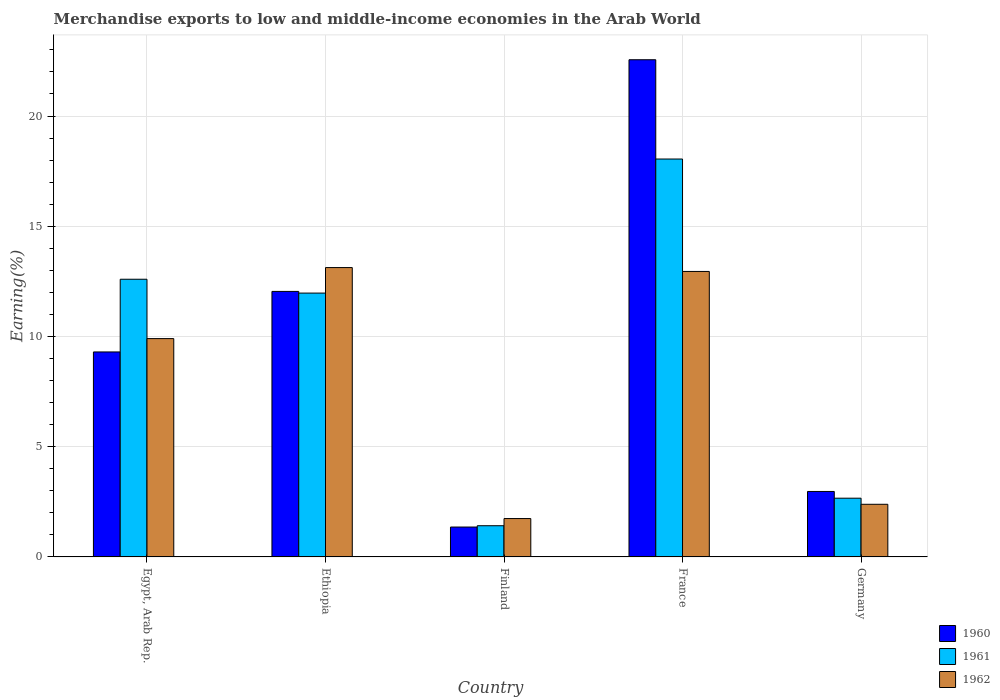How many groups of bars are there?
Offer a very short reply. 5. Are the number of bars per tick equal to the number of legend labels?
Keep it short and to the point. Yes. How many bars are there on the 5th tick from the left?
Your answer should be very brief. 3. What is the label of the 2nd group of bars from the left?
Give a very brief answer. Ethiopia. What is the percentage of amount earned from merchandise exports in 1961 in Ethiopia?
Give a very brief answer. 11.97. Across all countries, what is the maximum percentage of amount earned from merchandise exports in 1960?
Ensure brevity in your answer.  22.55. Across all countries, what is the minimum percentage of amount earned from merchandise exports in 1960?
Make the answer very short. 1.36. In which country was the percentage of amount earned from merchandise exports in 1961 maximum?
Your answer should be very brief. France. What is the total percentage of amount earned from merchandise exports in 1962 in the graph?
Your answer should be very brief. 40.11. What is the difference between the percentage of amount earned from merchandise exports in 1960 in Egypt, Arab Rep. and that in Germany?
Your response must be concise. 6.33. What is the difference between the percentage of amount earned from merchandise exports in 1961 in Ethiopia and the percentage of amount earned from merchandise exports in 1960 in France?
Provide a succinct answer. -10.58. What is the average percentage of amount earned from merchandise exports in 1962 per country?
Offer a terse response. 8.02. What is the difference between the percentage of amount earned from merchandise exports of/in 1961 and percentage of amount earned from merchandise exports of/in 1962 in Germany?
Your response must be concise. 0.28. What is the ratio of the percentage of amount earned from merchandise exports in 1961 in Finland to that in Germany?
Ensure brevity in your answer.  0.53. Is the percentage of amount earned from merchandise exports in 1960 in Ethiopia less than that in Germany?
Your answer should be compact. No. What is the difference between the highest and the second highest percentage of amount earned from merchandise exports in 1961?
Your answer should be compact. 6.08. What is the difference between the highest and the lowest percentage of amount earned from merchandise exports in 1960?
Keep it short and to the point. 21.2. Is the sum of the percentage of amount earned from merchandise exports in 1962 in Finland and Germany greater than the maximum percentage of amount earned from merchandise exports in 1961 across all countries?
Provide a succinct answer. No. What does the 1st bar from the right in Germany represents?
Your answer should be very brief. 1962. Is it the case that in every country, the sum of the percentage of amount earned from merchandise exports in 1962 and percentage of amount earned from merchandise exports in 1961 is greater than the percentage of amount earned from merchandise exports in 1960?
Your answer should be compact. Yes. Are all the bars in the graph horizontal?
Ensure brevity in your answer.  No. How many countries are there in the graph?
Your response must be concise. 5. What is the difference between two consecutive major ticks on the Y-axis?
Offer a terse response. 5. Are the values on the major ticks of Y-axis written in scientific E-notation?
Offer a terse response. No. Does the graph contain any zero values?
Keep it short and to the point. No. Does the graph contain grids?
Offer a terse response. Yes. Where does the legend appear in the graph?
Ensure brevity in your answer.  Bottom right. How many legend labels are there?
Keep it short and to the point. 3. What is the title of the graph?
Make the answer very short. Merchandise exports to low and middle-income economies in the Arab World. What is the label or title of the X-axis?
Provide a short and direct response. Country. What is the label or title of the Y-axis?
Provide a short and direct response. Earning(%). What is the Earning(%) in 1960 in Egypt, Arab Rep.?
Ensure brevity in your answer.  9.3. What is the Earning(%) of 1961 in Egypt, Arab Rep.?
Ensure brevity in your answer.  12.6. What is the Earning(%) in 1962 in Egypt, Arab Rep.?
Offer a terse response. 9.9. What is the Earning(%) in 1960 in Ethiopia?
Provide a short and direct response. 12.04. What is the Earning(%) of 1961 in Ethiopia?
Ensure brevity in your answer.  11.97. What is the Earning(%) in 1962 in Ethiopia?
Give a very brief answer. 13.12. What is the Earning(%) of 1960 in Finland?
Offer a very short reply. 1.36. What is the Earning(%) in 1961 in Finland?
Ensure brevity in your answer.  1.42. What is the Earning(%) in 1962 in Finland?
Keep it short and to the point. 1.74. What is the Earning(%) of 1960 in France?
Give a very brief answer. 22.55. What is the Earning(%) in 1961 in France?
Your response must be concise. 18.05. What is the Earning(%) of 1962 in France?
Provide a short and direct response. 12.95. What is the Earning(%) in 1960 in Germany?
Make the answer very short. 2.97. What is the Earning(%) in 1961 in Germany?
Make the answer very short. 2.66. What is the Earning(%) of 1962 in Germany?
Offer a terse response. 2.39. Across all countries, what is the maximum Earning(%) of 1960?
Your answer should be compact. 22.55. Across all countries, what is the maximum Earning(%) in 1961?
Provide a succinct answer. 18.05. Across all countries, what is the maximum Earning(%) of 1962?
Your answer should be very brief. 13.12. Across all countries, what is the minimum Earning(%) of 1960?
Provide a short and direct response. 1.36. Across all countries, what is the minimum Earning(%) of 1961?
Offer a very short reply. 1.42. Across all countries, what is the minimum Earning(%) of 1962?
Keep it short and to the point. 1.74. What is the total Earning(%) of 1960 in the graph?
Your answer should be compact. 48.22. What is the total Earning(%) of 1961 in the graph?
Ensure brevity in your answer.  46.69. What is the total Earning(%) of 1962 in the graph?
Offer a very short reply. 40.11. What is the difference between the Earning(%) of 1960 in Egypt, Arab Rep. and that in Ethiopia?
Your answer should be very brief. -2.75. What is the difference between the Earning(%) in 1961 in Egypt, Arab Rep. and that in Ethiopia?
Give a very brief answer. 0.63. What is the difference between the Earning(%) in 1962 in Egypt, Arab Rep. and that in Ethiopia?
Provide a short and direct response. -3.22. What is the difference between the Earning(%) of 1960 in Egypt, Arab Rep. and that in Finland?
Make the answer very short. 7.94. What is the difference between the Earning(%) in 1961 in Egypt, Arab Rep. and that in Finland?
Offer a terse response. 11.18. What is the difference between the Earning(%) in 1962 in Egypt, Arab Rep. and that in Finland?
Keep it short and to the point. 8.16. What is the difference between the Earning(%) of 1960 in Egypt, Arab Rep. and that in France?
Give a very brief answer. -13.25. What is the difference between the Earning(%) of 1961 in Egypt, Arab Rep. and that in France?
Make the answer very short. -5.45. What is the difference between the Earning(%) in 1962 in Egypt, Arab Rep. and that in France?
Your answer should be compact. -3.05. What is the difference between the Earning(%) in 1960 in Egypt, Arab Rep. and that in Germany?
Keep it short and to the point. 6.33. What is the difference between the Earning(%) of 1961 in Egypt, Arab Rep. and that in Germany?
Offer a very short reply. 9.93. What is the difference between the Earning(%) of 1962 in Egypt, Arab Rep. and that in Germany?
Give a very brief answer. 7.52. What is the difference between the Earning(%) of 1960 in Ethiopia and that in Finland?
Ensure brevity in your answer.  10.69. What is the difference between the Earning(%) in 1961 in Ethiopia and that in Finland?
Offer a very short reply. 10.55. What is the difference between the Earning(%) in 1962 in Ethiopia and that in Finland?
Offer a terse response. 11.38. What is the difference between the Earning(%) in 1960 in Ethiopia and that in France?
Offer a terse response. -10.51. What is the difference between the Earning(%) in 1961 in Ethiopia and that in France?
Your answer should be compact. -6.08. What is the difference between the Earning(%) of 1962 in Ethiopia and that in France?
Your answer should be very brief. 0.18. What is the difference between the Earning(%) in 1960 in Ethiopia and that in Germany?
Your answer should be compact. 9.07. What is the difference between the Earning(%) in 1961 in Ethiopia and that in Germany?
Keep it short and to the point. 9.3. What is the difference between the Earning(%) in 1962 in Ethiopia and that in Germany?
Make the answer very short. 10.74. What is the difference between the Earning(%) in 1960 in Finland and that in France?
Your answer should be compact. -21.2. What is the difference between the Earning(%) in 1961 in Finland and that in France?
Ensure brevity in your answer.  -16.63. What is the difference between the Earning(%) in 1962 in Finland and that in France?
Your answer should be very brief. -11.21. What is the difference between the Earning(%) of 1960 in Finland and that in Germany?
Provide a short and direct response. -1.61. What is the difference between the Earning(%) in 1961 in Finland and that in Germany?
Your answer should be compact. -1.25. What is the difference between the Earning(%) in 1962 in Finland and that in Germany?
Give a very brief answer. -0.65. What is the difference between the Earning(%) in 1960 in France and that in Germany?
Your response must be concise. 19.58. What is the difference between the Earning(%) of 1961 in France and that in Germany?
Your answer should be compact. 15.38. What is the difference between the Earning(%) in 1962 in France and that in Germany?
Your answer should be compact. 10.56. What is the difference between the Earning(%) of 1960 in Egypt, Arab Rep. and the Earning(%) of 1961 in Ethiopia?
Keep it short and to the point. -2.67. What is the difference between the Earning(%) of 1960 in Egypt, Arab Rep. and the Earning(%) of 1962 in Ethiopia?
Your answer should be very brief. -3.83. What is the difference between the Earning(%) in 1961 in Egypt, Arab Rep. and the Earning(%) in 1962 in Ethiopia?
Offer a terse response. -0.53. What is the difference between the Earning(%) in 1960 in Egypt, Arab Rep. and the Earning(%) in 1961 in Finland?
Your answer should be very brief. 7.88. What is the difference between the Earning(%) in 1960 in Egypt, Arab Rep. and the Earning(%) in 1962 in Finland?
Give a very brief answer. 7.56. What is the difference between the Earning(%) of 1961 in Egypt, Arab Rep. and the Earning(%) of 1962 in Finland?
Your answer should be very brief. 10.85. What is the difference between the Earning(%) of 1960 in Egypt, Arab Rep. and the Earning(%) of 1961 in France?
Offer a terse response. -8.75. What is the difference between the Earning(%) in 1960 in Egypt, Arab Rep. and the Earning(%) in 1962 in France?
Your response must be concise. -3.65. What is the difference between the Earning(%) of 1961 in Egypt, Arab Rep. and the Earning(%) of 1962 in France?
Your answer should be very brief. -0.35. What is the difference between the Earning(%) of 1960 in Egypt, Arab Rep. and the Earning(%) of 1961 in Germany?
Provide a short and direct response. 6.63. What is the difference between the Earning(%) of 1960 in Egypt, Arab Rep. and the Earning(%) of 1962 in Germany?
Provide a short and direct response. 6.91. What is the difference between the Earning(%) in 1961 in Egypt, Arab Rep. and the Earning(%) in 1962 in Germany?
Give a very brief answer. 10.21. What is the difference between the Earning(%) of 1960 in Ethiopia and the Earning(%) of 1961 in Finland?
Offer a terse response. 10.63. What is the difference between the Earning(%) in 1960 in Ethiopia and the Earning(%) in 1962 in Finland?
Offer a terse response. 10.3. What is the difference between the Earning(%) in 1961 in Ethiopia and the Earning(%) in 1962 in Finland?
Provide a succinct answer. 10.23. What is the difference between the Earning(%) in 1960 in Ethiopia and the Earning(%) in 1961 in France?
Keep it short and to the point. -6.01. What is the difference between the Earning(%) of 1960 in Ethiopia and the Earning(%) of 1962 in France?
Your answer should be compact. -0.91. What is the difference between the Earning(%) of 1961 in Ethiopia and the Earning(%) of 1962 in France?
Your answer should be very brief. -0.98. What is the difference between the Earning(%) in 1960 in Ethiopia and the Earning(%) in 1961 in Germany?
Ensure brevity in your answer.  9.38. What is the difference between the Earning(%) in 1960 in Ethiopia and the Earning(%) in 1962 in Germany?
Your response must be concise. 9.66. What is the difference between the Earning(%) of 1961 in Ethiopia and the Earning(%) of 1962 in Germany?
Ensure brevity in your answer.  9.58. What is the difference between the Earning(%) in 1960 in Finland and the Earning(%) in 1961 in France?
Provide a succinct answer. -16.69. What is the difference between the Earning(%) of 1960 in Finland and the Earning(%) of 1962 in France?
Provide a short and direct response. -11.59. What is the difference between the Earning(%) of 1961 in Finland and the Earning(%) of 1962 in France?
Offer a terse response. -11.53. What is the difference between the Earning(%) in 1960 in Finland and the Earning(%) in 1961 in Germany?
Your response must be concise. -1.31. What is the difference between the Earning(%) of 1960 in Finland and the Earning(%) of 1962 in Germany?
Ensure brevity in your answer.  -1.03. What is the difference between the Earning(%) in 1961 in Finland and the Earning(%) in 1962 in Germany?
Provide a succinct answer. -0.97. What is the difference between the Earning(%) of 1960 in France and the Earning(%) of 1961 in Germany?
Make the answer very short. 19.89. What is the difference between the Earning(%) in 1960 in France and the Earning(%) in 1962 in Germany?
Make the answer very short. 20.16. What is the difference between the Earning(%) of 1961 in France and the Earning(%) of 1962 in Germany?
Ensure brevity in your answer.  15.66. What is the average Earning(%) in 1960 per country?
Provide a succinct answer. 9.64. What is the average Earning(%) in 1961 per country?
Provide a succinct answer. 9.34. What is the average Earning(%) in 1962 per country?
Give a very brief answer. 8.02. What is the difference between the Earning(%) of 1960 and Earning(%) of 1961 in Egypt, Arab Rep.?
Your response must be concise. -3.3. What is the difference between the Earning(%) in 1960 and Earning(%) in 1962 in Egypt, Arab Rep.?
Your response must be concise. -0.61. What is the difference between the Earning(%) of 1961 and Earning(%) of 1962 in Egypt, Arab Rep.?
Keep it short and to the point. 2.69. What is the difference between the Earning(%) in 1960 and Earning(%) in 1961 in Ethiopia?
Offer a terse response. 0.08. What is the difference between the Earning(%) of 1960 and Earning(%) of 1962 in Ethiopia?
Ensure brevity in your answer.  -1.08. What is the difference between the Earning(%) of 1961 and Earning(%) of 1962 in Ethiopia?
Offer a terse response. -1.16. What is the difference between the Earning(%) in 1960 and Earning(%) in 1961 in Finland?
Your answer should be compact. -0.06. What is the difference between the Earning(%) in 1960 and Earning(%) in 1962 in Finland?
Your answer should be very brief. -0.38. What is the difference between the Earning(%) in 1961 and Earning(%) in 1962 in Finland?
Provide a short and direct response. -0.33. What is the difference between the Earning(%) of 1960 and Earning(%) of 1961 in France?
Offer a very short reply. 4.5. What is the difference between the Earning(%) of 1960 and Earning(%) of 1962 in France?
Your response must be concise. 9.6. What is the difference between the Earning(%) of 1961 and Earning(%) of 1962 in France?
Ensure brevity in your answer.  5.1. What is the difference between the Earning(%) in 1960 and Earning(%) in 1961 in Germany?
Offer a very short reply. 0.31. What is the difference between the Earning(%) of 1960 and Earning(%) of 1962 in Germany?
Offer a very short reply. 0.58. What is the difference between the Earning(%) of 1961 and Earning(%) of 1962 in Germany?
Provide a succinct answer. 0.28. What is the ratio of the Earning(%) in 1960 in Egypt, Arab Rep. to that in Ethiopia?
Give a very brief answer. 0.77. What is the ratio of the Earning(%) of 1961 in Egypt, Arab Rep. to that in Ethiopia?
Your response must be concise. 1.05. What is the ratio of the Earning(%) in 1962 in Egypt, Arab Rep. to that in Ethiopia?
Make the answer very short. 0.75. What is the ratio of the Earning(%) of 1960 in Egypt, Arab Rep. to that in Finland?
Offer a very short reply. 6.86. What is the ratio of the Earning(%) of 1961 in Egypt, Arab Rep. to that in Finland?
Give a very brief answer. 8.9. What is the ratio of the Earning(%) of 1962 in Egypt, Arab Rep. to that in Finland?
Keep it short and to the point. 5.69. What is the ratio of the Earning(%) in 1960 in Egypt, Arab Rep. to that in France?
Ensure brevity in your answer.  0.41. What is the ratio of the Earning(%) of 1961 in Egypt, Arab Rep. to that in France?
Offer a very short reply. 0.7. What is the ratio of the Earning(%) of 1962 in Egypt, Arab Rep. to that in France?
Offer a terse response. 0.76. What is the ratio of the Earning(%) of 1960 in Egypt, Arab Rep. to that in Germany?
Ensure brevity in your answer.  3.13. What is the ratio of the Earning(%) of 1961 in Egypt, Arab Rep. to that in Germany?
Keep it short and to the point. 4.73. What is the ratio of the Earning(%) in 1962 in Egypt, Arab Rep. to that in Germany?
Provide a short and direct response. 4.15. What is the ratio of the Earning(%) of 1960 in Ethiopia to that in Finland?
Your answer should be compact. 8.88. What is the ratio of the Earning(%) in 1961 in Ethiopia to that in Finland?
Your answer should be very brief. 8.46. What is the ratio of the Earning(%) of 1962 in Ethiopia to that in Finland?
Keep it short and to the point. 7.54. What is the ratio of the Earning(%) in 1960 in Ethiopia to that in France?
Keep it short and to the point. 0.53. What is the ratio of the Earning(%) in 1961 in Ethiopia to that in France?
Offer a terse response. 0.66. What is the ratio of the Earning(%) of 1962 in Ethiopia to that in France?
Keep it short and to the point. 1.01. What is the ratio of the Earning(%) in 1960 in Ethiopia to that in Germany?
Your response must be concise. 4.06. What is the ratio of the Earning(%) in 1961 in Ethiopia to that in Germany?
Provide a succinct answer. 4.49. What is the ratio of the Earning(%) in 1962 in Ethiopia to that in Germany?
Make the answer very short. 5.5. What is the ratio of the Earning(%) in 1960 in Finland to that in France?
Offer a terse response. 0.06. What is the ratio of the Earning(%) of 1961 in Finland to that in France?
Ensure brevity in your answer.  0.08. What is the ratio of the Earning(%) in 1962 in Finland to that in France?
Ensure brevity in your answer.  0.13. What is the ratio of the Earning(%) in 1960 in Finland to that in Germany?
Make the answer very short. 0.46. What is the ratio of the Earning(%) of 1961 in Finland to that in Germany?
Ensure brevity in your answer.  0.53. What is the ratio of the Earning(%) of 1962 in Finland to that in Germany?
Your answer should be very brief. 0.73. What is the ratio of the Earning(%) of 1960 in France to that in Germany?
Provide a succinct answer. 7.59. What is the ratio of the Earning(%) in 1961 in France to that in Germany?
Your answer should be very brief. 6.78. What is the ratio of the Earning(%) of 1962 in France to that in Germany?
Provide a short and direct response. 5.42. What is the difference between the highest and the second highest Earning(%) in 1960?
Make the answer very short. 10.51. What is the difference between the highest and the second highest Earning(%) in 1961?
Give a very brief answer. 5.45. What is the difference between the highest and the second highest Earning(%) in 1962?
Provide a succinct answer. 0.18. What is the difference between the highest and the lowest Earning(%) of 1960?
Offer a very short reply. 21.2. What is the difference between the highest and the lowest Earning(%) of 1961?
Your answer should be compact. 16.63. What is the difference between the highest and the lowest Earning(%) of 1962?
Offer a very short reply. 11.38. 